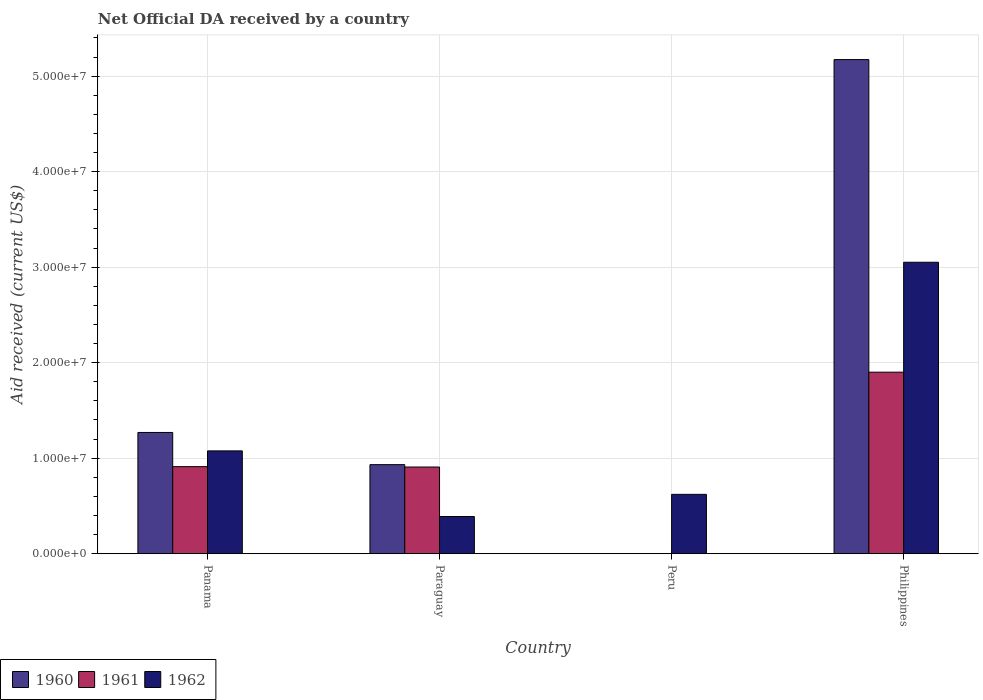How many different coloured bars are there?
Offer a very short reply. 3. Are the number of bars per tick equal to the number of legend labels?
Give a very brief answer. No. How many bars are there on the 4th tick from the left?
Give a very brief answer. 3. What is the label of the 4th group of bars from the left?
Provide a short and direct response. Philippines. What is the net official development assistance aid received in 1960 in Paraguay?
Keep it short and to the point. 9.32e+06. Across all countries, what is the maximum net official development assistance aid received in 1961?
Provide a short and direct response. 1.90e+07. Across all countries, what is the minimum net official development assistance aid received in 1960?
Offer a terse response. 0. In which country was the net official development assistance aid received in 1960 maximum?
Your answer should be very brief. Philippines. What is the total net official development assistance aid received in 1961 in the graph?
Ensure brevity in your answer.  3.72e+07. What is the difference between the net official development assistance aid received in 1962 in Panama and that in Peru?
Your response must be concise. 4.55e+06. What is the difference between the net official development assistance aid received in 1961 in Peru and the net official development assistance aid received in 1962 in Paraguay?
Offer a very short reply. -3.89e+06. What is the average net official development assistance aid received in 1962 per country?
Keep it short and to the point. 1.28e+07. What is the difference between the net official development assistance aid received of/in 1962 and net official development assistance aid received of/in 1960 in Panama?
Make the answer very short. -1.93e+06. What is the ratio of the net official development assistance aid received in 1960 in Paraguay to that in Philippines?
Offer a terse response. 0.18. Is the difference between the net official development assistance aid received in 1962 in Paraguay and Philippines greater than the difference between the net official development assistance aid received in 1960 in Paraguay and Philippines?
Offer a very short reply. Yes. What is the difference between the highest and the second highest net official development assistance aid received in 1961?
Offer a terse response. 9.89e+06. What is the difference between the highest and the lowest net official development assistance aid received in 1960?
Your response must be concise. 5.17e+07. In how many countries, is the net official development assistance aid received in 1961 greater than the average net official development assistance aid received in 1961 taken over all countries?
Keep it short and to the point. 1. Is it the case that in every country, the sum of the net official development assistance aid received in 1961 and net official development assistance aid received in 1962 is greater than the net official development assistance aid received in 1960?
Provide a short and direct response. No. How many bars are there?
Ensure brevity in your answer.  10. How many countries are there in the graph?
Your response must be concise. 4. What is the difference between two consecutive major ticks on the Y-axis?
Provide a succinct answer. 1.00e+07. Does the graph contain any zero values?
Offer a very short reply. Yes. Does the graph contain grids?
Your answer should be compact. Yes. Where does the legend appear in the graph?
Your response must be concise. Bottom left. How many legend labels are there?
Offer a terse response. 3. What is the title of the graph?
Your response must be concise. Net Official DA received by a country. What is the label or title of the X-axis?
Give a very brief answer. Country. What is the label or title of the Y-axis?
Your answer should be compact. Aid received (current US$). What is the Aid received (current US$) in 1960 in Panama?
Make the answer very short. 1.27e+07. What is the Aid received (current US$) in 1961 in Panama?
Provide a short and direct response. 9.11e+06. What is the Aid received (current US$) of 1962 in Panama?
Offer a terse response. 1.08e+07. What is the Aid received (current US$) in 1960 in Paraguay?
Offer a very short reply. 9.32e+06. What is the Aid received (current US$) of 1961 in Paraguay?
Provide a succinct answer. 9.07e+06. What is the Aid received (current US$) in 1962 in Paraguay?
Your answer should be very brief. 3.89e+06. What is the Aid received (current US$) in 1961 in Peru?
Make the answer very short. 0. What is the Aid received (current US$) of 1962 in Peru?
Offer a terse response. 6.21e+06. What is the Aid received (current US$) in 1960 in Philippines?
Keep it short and to the point. 5.17e+07. What is the Aid received (current US$) of 1961 in Philippines?
Provide a succinct answer. 1.90e+07. What is the Aid received (current US$) of 1962 in Philippines?
Provide a succinct answer. 3.05e+07. Across all countries, what is the maximum Aid received (current US$) of 1960?
Your answer should be very brief. 5.17e+07. Across all countries, what is the maximum Aid received (current US$) in 1961?
Your answer should be very brief. 1.90e+07. Across all countries, what is the maximum Aid received (current US$) in 1962?
Make the answer very short. 3.05e+07. Across all countries, what is the minimum Aid received (current US$) of 1960?
Your answer should be compact. 0. Across all countries, what is the minimum Aid received (current US$) in 1961?
Make the answer very short. 0. Across all countries, what is the minimum Aid received (current US$) of 1962?
Make the answer very short. 3.89e+06. What is the total Aid received (current US$) in 1960 in the graph?
Provide a succinct answer. 7.37e+07. What is the total Aid received (current US$) in 1961 in the graph?
Your answer should be very brief. 3.72e+07. What is the total Aid received (current US$) of 1962 in the graph?
Make the answer very short. 5.14e+07. What is the difference between the Aid received (current US$) in 1960 in Panama and that in Paraguay?
Ensure brevity in your answer.  3.37e+06. What is the difference between the Aid received (current US$) in 1962 in Panama and that in Paraguay?
Your answer should be compact. 6.87e+06. What is the difference between the Aid received (current US$) in 1962 in Panama and that in Peru?
Your answer should be compact. 4.55e+06. What is the difference between the Aid received (current US$) of 1960 in Panama and that in Philippines?
Offer a terse response. -3.90e+07. What is the difference between the Aid received (current US$) in 1961 in Panama and that in Philippines?
Provide a short and direct response. -9.89e+06. What is the difference between the Aid received (current US$) of 1962 in Panama and that in Philippines?
Make the answer very short. -1.98e+07. What is the difference between the Aid received (current US$) of 1962 in Paraguay and that in Peru?
Provide a succinct answer. -2.32e+06. What is the difference between the Aid received (current US$) in 1960 in Paraguay and that in Philippines?
Keep it short and to the point. -4.24e+07. What is the difference between the Aid received (current US$) of 1961 in Paraguay and that in Philippines?
Ensure brevity in your answer.  -9.93e+06. What is the difference between the Aid received (current US$) in 1962 in Paraguay and that in Philippines?
Your response must be concise. -2.66e+07. What is the difference between the Aid received (current US$) in 1962 in Peru and that in Philippines?
Your response must be concise. -2.43e+07. What is the difference between the Aid received (current US$) of 1960 in Panama and the Aid received (current US$) of 1961 in Paraguay?
Make the answer very short. 3.62e+06. What is the difference between the Aid received (current US$) in 1960 in Panama and the Aid received (current US$) in 1962 in Paraguay?
Give a very brief answer. 8.80e+06. What is the difference between the Aid received (current US$) in 1961 in Panama and the Aid received (current US$) in 1962 in Paraguay?
Your response must be concise. 5.22e+06. What is the difference between the Aid received (current US$) in 1960 in Panama and the Aid received (current US$) in 1962 in Peru?
Offer a terse response. 6.48e+06. What is the difference between the Aid received (current US$) in 1961 in Panama and the Aid received (current US$) in 1962 in Peru?
Offer a very short reply. 2.90e+06. What is the difference between the Aid received (current US$) in 1960 in Panama and the Aid received (current US$) in 1961 in Philippines?
Offer a terse response. -6.31e+06. What is the difference between the Aid received (current US$) of 1960 in Panama and the Aid received (current US$) of 1962 in Philippines?
Keep it short and to the point. -1.78e+07. What is the difference between the Aid received (current US$) in 1961 in Panama and the Aid received (current US$) in 1962 in Philippines?
Your response must be concise. -2.14e+07. What is the difference between the Aid received (current US$) in 1960 in Paraguay and the Aid received (current US$) in 1962 in Peru?
Keep it short and to the point. 3.11e+06. What is the difference between the Aid received (current US$) of 1961 in Paraguay and the Aid received (current US$) of 1962 in Peru?
Make the answer very short. 2.86e+06. What is the difference between the Aid received (current US$) in 1960 in Paraguay and the Aid received (current US$) in 1961 in Philippines?
Your answer should be very brief. -9.68e+06. What is the difference between the Aid received (current US$) in 1960 in Paraguay and the Aid received (current US$) in 1962 in Philippines?
Offer a very short reply. -2.12e+07. What is the difference between the Aid received (current US$) in 1961 in Paraguay and the Aid received (current US$) in 1962 in Philippines?
Offer a terse response. -2.14e+07. What is the average Aid received (current US$) in 1960 per country?
Offer a terse response. 1.84e+07. What is the average Aid received (current US$) of 1961 per country?
Give a very brief answer. 9.30e+06. What is the average Aid received (current US$) in 1962 per country?
Ensure brevity in your answer.  1.28e+07. What is the difference between the Aid received (current US$) of 1960 and Aid received (current US$) of 1961 in Panama?
Offer a very short reply. 3.58e+06. What is the difference between the Aid received (current US$) in 1960 and Aid received (current US$) in 1962 in Panama?
Ensure brevity in your answer.  1.93e+06. What is the difference between the Aid received (current US$) of 1961 and Aid received (current US$) of 1962 in Panama?
Provide a short and direct response. -1.65e+06. What is the difference between the Aid received (current US$) in 1960 and Aid received (current US$) in 1961 in Paraguay?
Offer a very short reply. 2.50e+05. What is the difference between the Aid received (current US$) of 1960 and Aid received (current US$) of 1962 in Paraguay?
Give a very brief answer. 5.43e+06. What is the difference between the Aid received (current US$) in 1961 and Aid received (current US$) in 1962 in Paraguay?
Ensure brevity in your answer.  5.18e+06. What is the difference between the Aid received (current US$) in 1960 and Aid received (current US$) in 1961 in Philippines?
Offer a very short reply. 3.27e+07. What is the difference between the Aid received (current US$) of 1960 and Aid received (current US$) of 1962 in Philippines?
Provide a short and direct response. 2.12e+07. What is the difference between the Aid received (current US$) of 1961 and Aid received (current US$) of 1962 in Philippines?
Your response must be concise. -1.15e+07. What is the ratio of the Aid received (current US$) in 1960 in Panama to that in Paraguay?
Make the answer very short. 1.36. What is the ratio of the Aid received (current US$) of 1961 in Panama to that in Paraguay?
Keep it short and to the point. 1. What is the ratio of the Aid received (current US$) in 1962 in Panama to that in Paraguay?
Provide a succinct answer. 2.77. What is the ratio of the Aid received (current US$) in 1962 in Panama to that in Peru?
Your response must be concise. 1.73. What is the ratio of the Aid received (current US$) in 1960 in Panama to that in Philippines?
Provide a succinct answer. 0.25. What is the ratio of the Aid received (current US$) in 1961 in Panama to that in Philippines?
Make the answer very short. 0.48. What is the ratio of the Aid received (current US$) in 1962 in Panama to that in Philippines?
Offer a terse response. 0.35. What is the ratio of the Aid received (current US$) of 1962 in Paraguay to that in Peru?
Provide a short and direct response. 0.63. What is the ratio of the Aid received (current US$) in 1960 in Paraguay to that in Philippines?
Provide a succinct answer. 0.18. What is the ratio of the Aid received (current US$) of 1961 in Paraguay to that in Philippines?
Provide a succinct answer. 0.48. What is the ratio of the Aid received (current US$) of 1962 in Paraguay to that in Philippines?
Provide a succinct answer. 0.13. What is the ratio of the Aid received (current US$) in 1962 in Peru to that in Philippines?
Offer a very short reply. 0.2. What is the difference between the highest and the second highest Aid received (current US$) in 1960?
Offer a terse response. 3.90e+07. What is the difference between the highest and the second highest Aid received (current US$) in 1961?
Your answer should be compact. 9.89e+06. What is the difference between the highest and the second highest Aid received (current US$) in 1962?
Make the answer very short. 1.98e+07. What is the difference between the highest and the lowest Aid received (current US$) in 1960?
Offer a very short reply. 5.17e+07. What is the difference between the highest and the lowest Aid received (current US$) in 1961?
Ensure brevity in your answer.  1.90e+07. What is the difference between the highest and the lowest Aid received (current US$) of 1962?
Your answer should be very brief. 2.66e+07. 